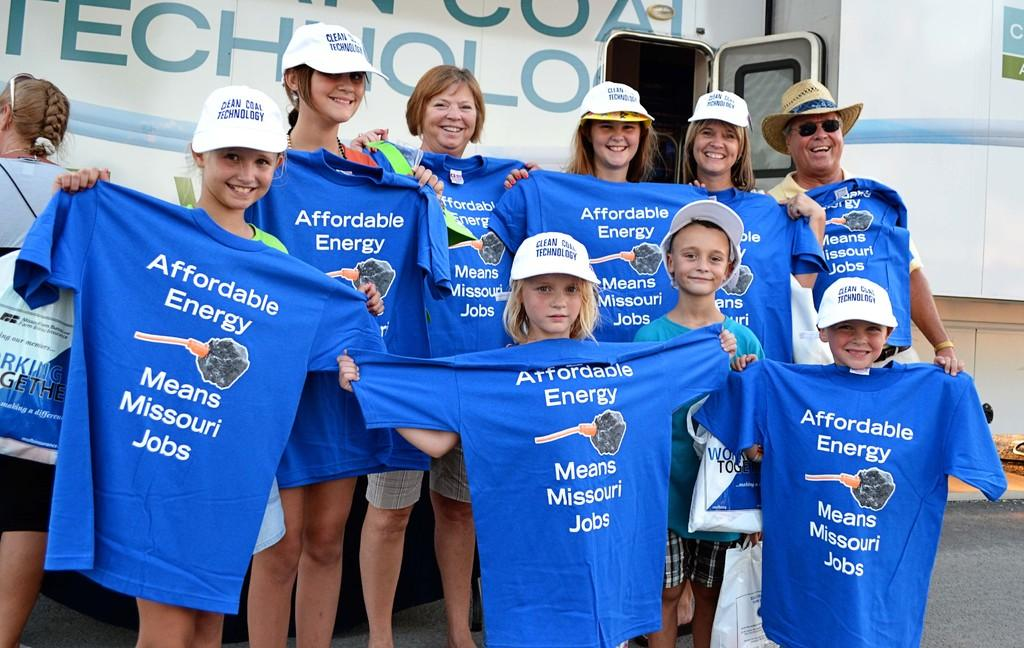<image>
Share a concise interpretation of the image provided. The shirts are to promote Affordable Energy and Jobs 